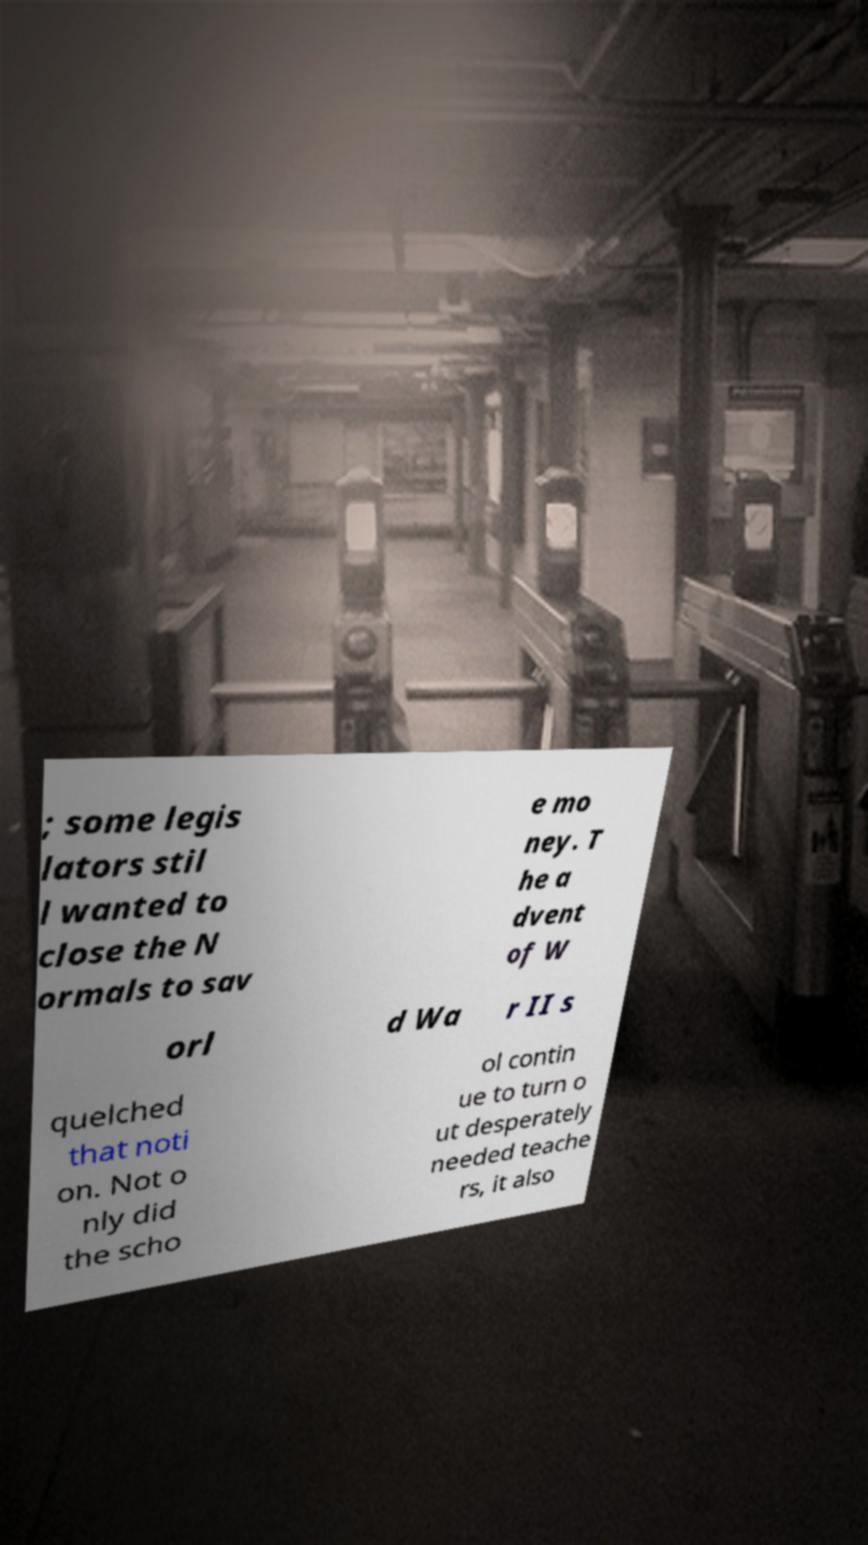For documentation purposes, I need the text within this image transcribed. Could you provide that? ; some legis lators stil l wanted to close the N ormals to sav e mo ney. T he a dvent of W orl d Wa r II s quelched that noti on. Not o nly did the scho ol contin ue to turn o ut desperately needed teache rs, it also 